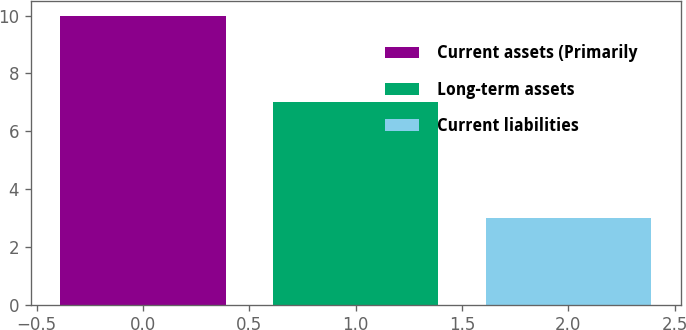Convert chart. <chart><loc_0><loc_0><loc_500><loc_500><bar_chart><fcel>Current assets (Primarily<fcel>Long-term assets<fcel>Current liabilities<nl><fcel>10<fcel>7<fcel>3<nl></chart> 